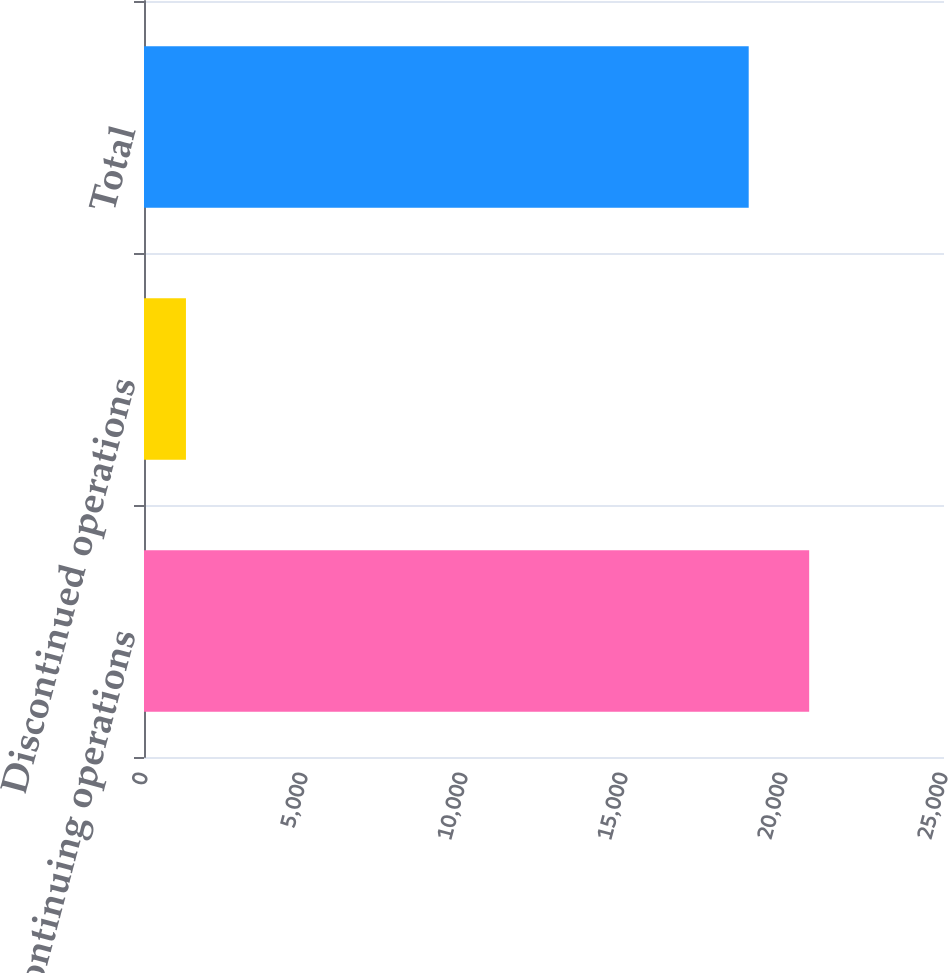Convert chart to OTSL. <chart><loc_0><loc_0><loc_500><loc_500><bar_chart><fcel>Continuing operations<fcel>Discontinued operations<fcel>Total<nl><fcel>20786.7<fcel>1311<fcel>18897<nl></chart> 